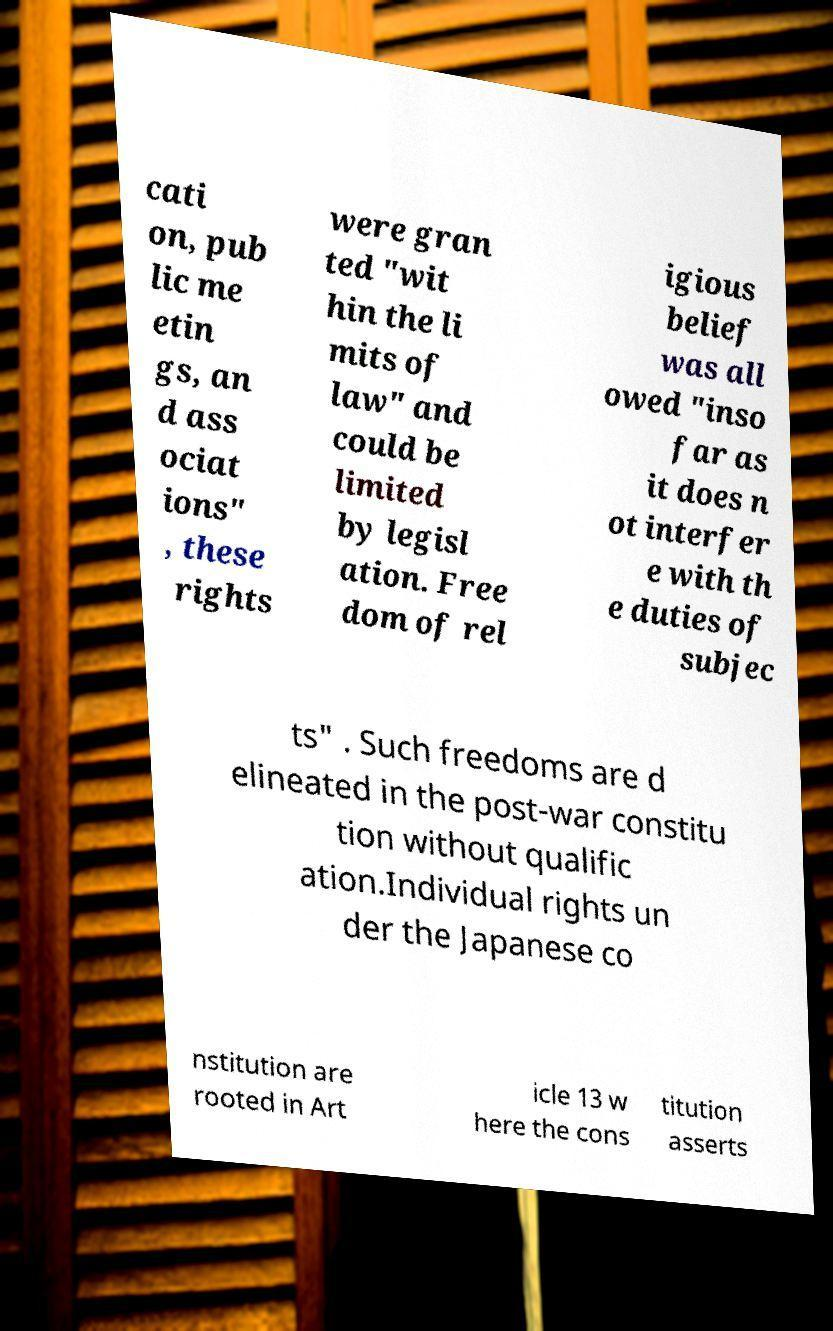I need the written content from this picture converted into text. Can you do that? cati on, pub lic me etin gs, an d ass ociat ions" , these rights were gran ted "wit hin the li mits of law" and could be limited by legisl ation. Free dom of rel igious belief was all owed "inso far as it does n ot interfer e with th e duties of subjec ts" . Such freedoms are d elineated in the post-war constitu tion without qualific ation.Individual rights un der the Japanese co nstitution are rooted in Art icle 13 w here the cons titution asserts 